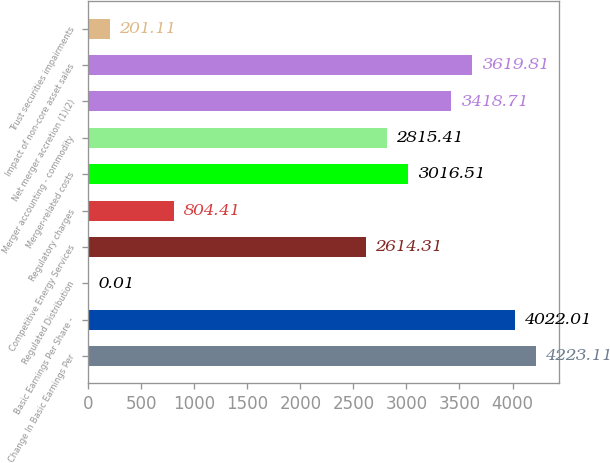Convert chart. <chart><loc_0><loc_0><loc_500><loc_500><bar_chart><fcel>Change In Basic Earnings Per<fcel>Basic Earnings Per Share -<fcel>Regulated Distribution<fcel>Competitive Energy Services<fcel>Regulatory charges<fcel>Merger-related costs<fcel>Merger accounting - commodity<fcel>Net merger accretion (1)(2)<fcel>Impact of non-core asset sales<fcel>Trust securities impairments<nl><fcel>4223.11<fcel>4022.01<fcel>0.01<fcel>2614.31<fcel>804.41<fcel>3016.51<fcel>2815.41<fcel>3418.71<fcel>3619.81<fcel>201.11<nl></chart> 